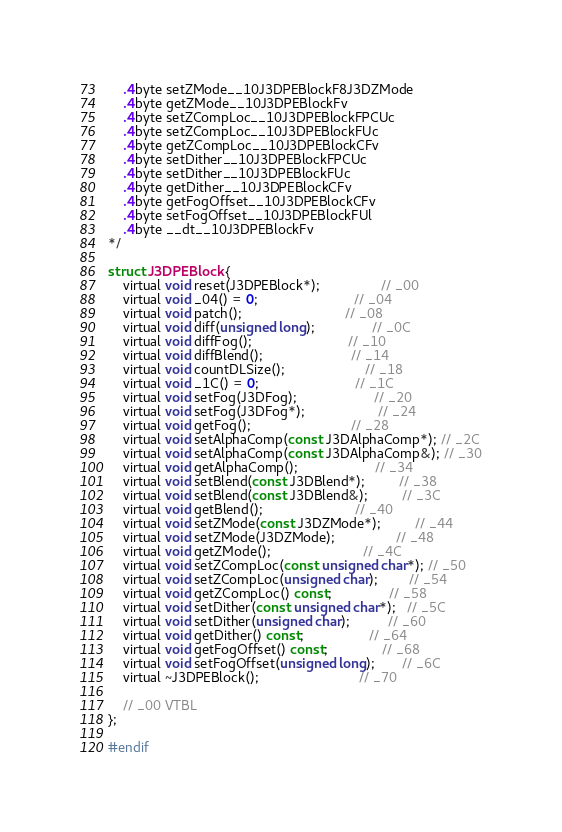<code> <loc_0><loc_0><loc_500><loc_500><_C_>    .4byte setZMode__10J3DPEBlockF8J3DZMode
    .4byte getZMode__10J3DPEBlockFv
    .4byte setZCompLoc__10J3DPEBlockFPCUc
    .4byte setZCompLoc__10J3DPEBlockFUc
    .4byte getZCompLoc__10J3DPEBlockCFv
    .4byte setDither__10J3DPEBlockFPCUc
    .4byte setDither__10J3DPEBlockFUc
    .4byte getDither__10J3DPEBlockCFv
    .4byte getFogOffset__10J3DPEBlockCFv
    .4byte setFogOffset__10J3DPEBlockFUl
    .4byte __dt__10J3DPEBlockFv
*/

struct J3DPEBlock {
	virtual void reset(J3DPEBlock*);                // _00
	virtual void _04() = 0;                         // _04
	virtual void patch();                           // _08
	virtual void diff(unsigned long);               // _0C
	virtual void diffFog();                         // _10
	virtual void diffBlend();                       // _14
	virtual void countDLSize();                     // _18
	virtual void _1C() = 0;                         // _1C
	virtual void setFog(J3DFog);                    // _20
	virtual void setFog(J3DFog*);                   // _24
	virtual void getFog();                          // _28
	virtual void setAlphaComp(const J3DAlphaComp*); // _2C
	virtual void setAlphaComp(const J3DAlphaComp&); // _30
	virtual void getAlphaComp();                    // _34
	virtual void setBlend(const J3DBlend*);         // _38
	virtual void setBlend(const J3DBlend&);         // _3C
	virtual void getBlend();                        // _40
	virtual void setZMode(const J3DZMode*);         // _44
	virtual void setZMode(J3DZMode);                // _48
	virtual void getZMode();                        // _4C
	virtual void setZCompLoc(const unsigned char*); // _50
	virtual void setZCompLoc(unsigned char);        // _54
	virtual void getZCompLoc() const;               // _58
	virtual void setDither(const unsigned char*);   // _5C
	virtual void setDither(unsigned char);          // _60
	virtual void getDither() const;                 // _64
	virtual void getFogOffset() const;              // _68
	virtual void setFogOffset(unsigned long);       // _6C
	virtual ~J3DPEBlock();                          // _70

	// _00 VTBL
};

#endif
</code> 